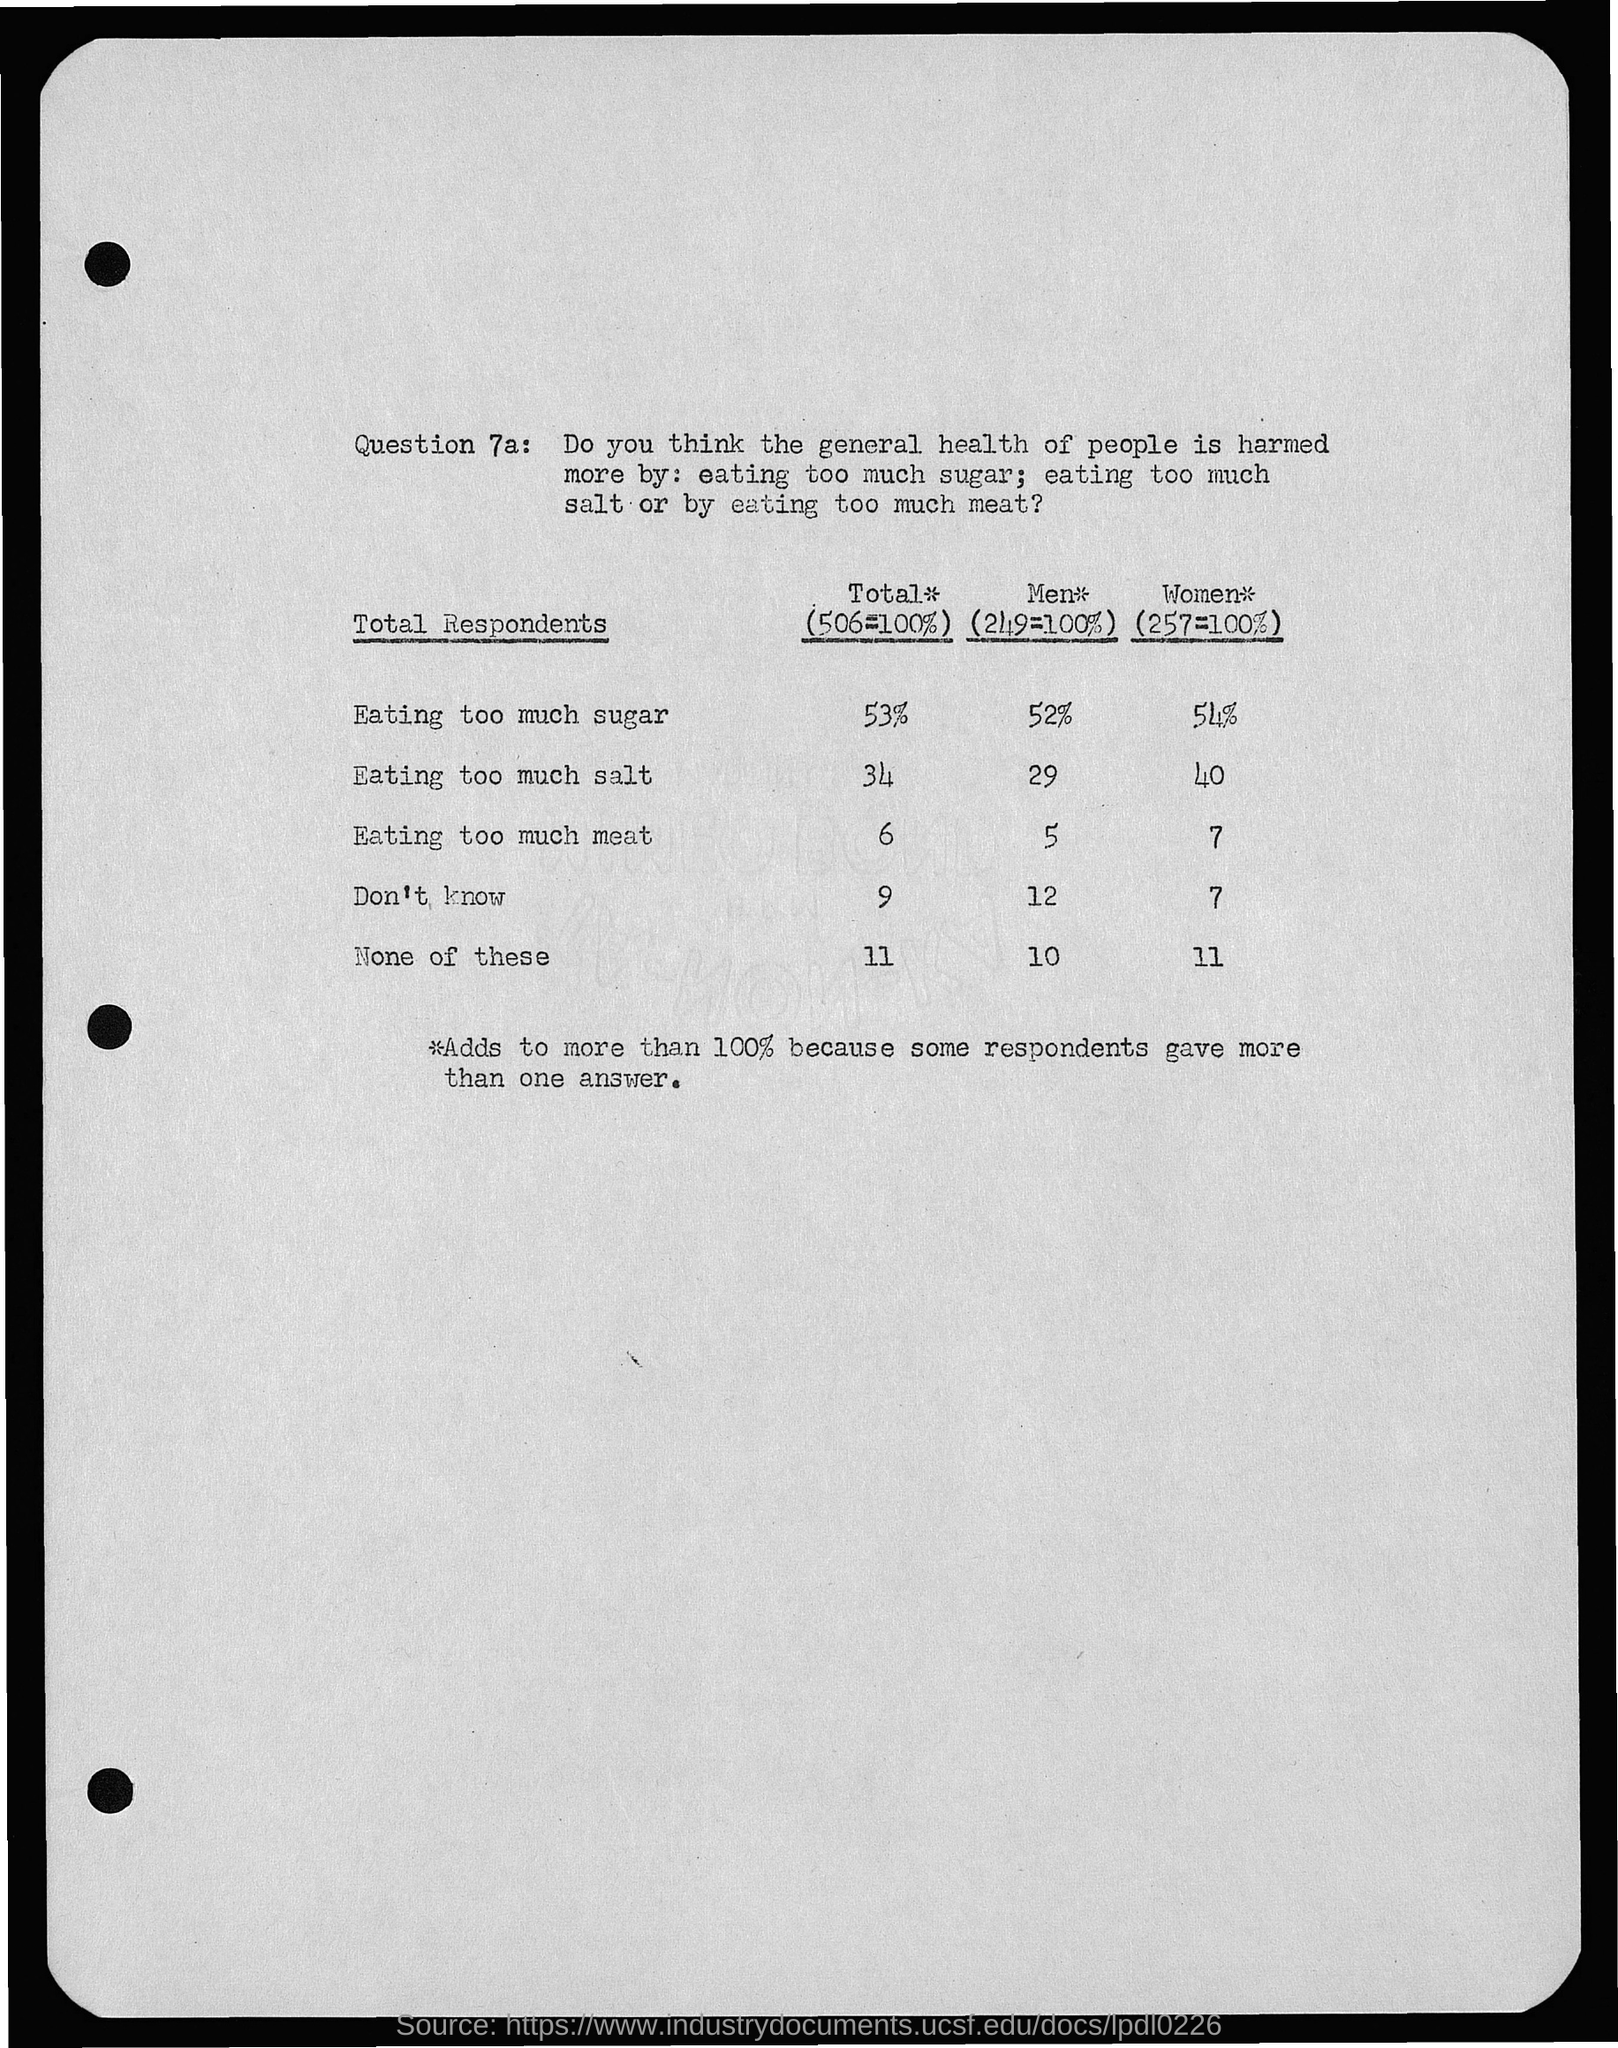What is the percentage of eating too much sugar in women?
 54% 